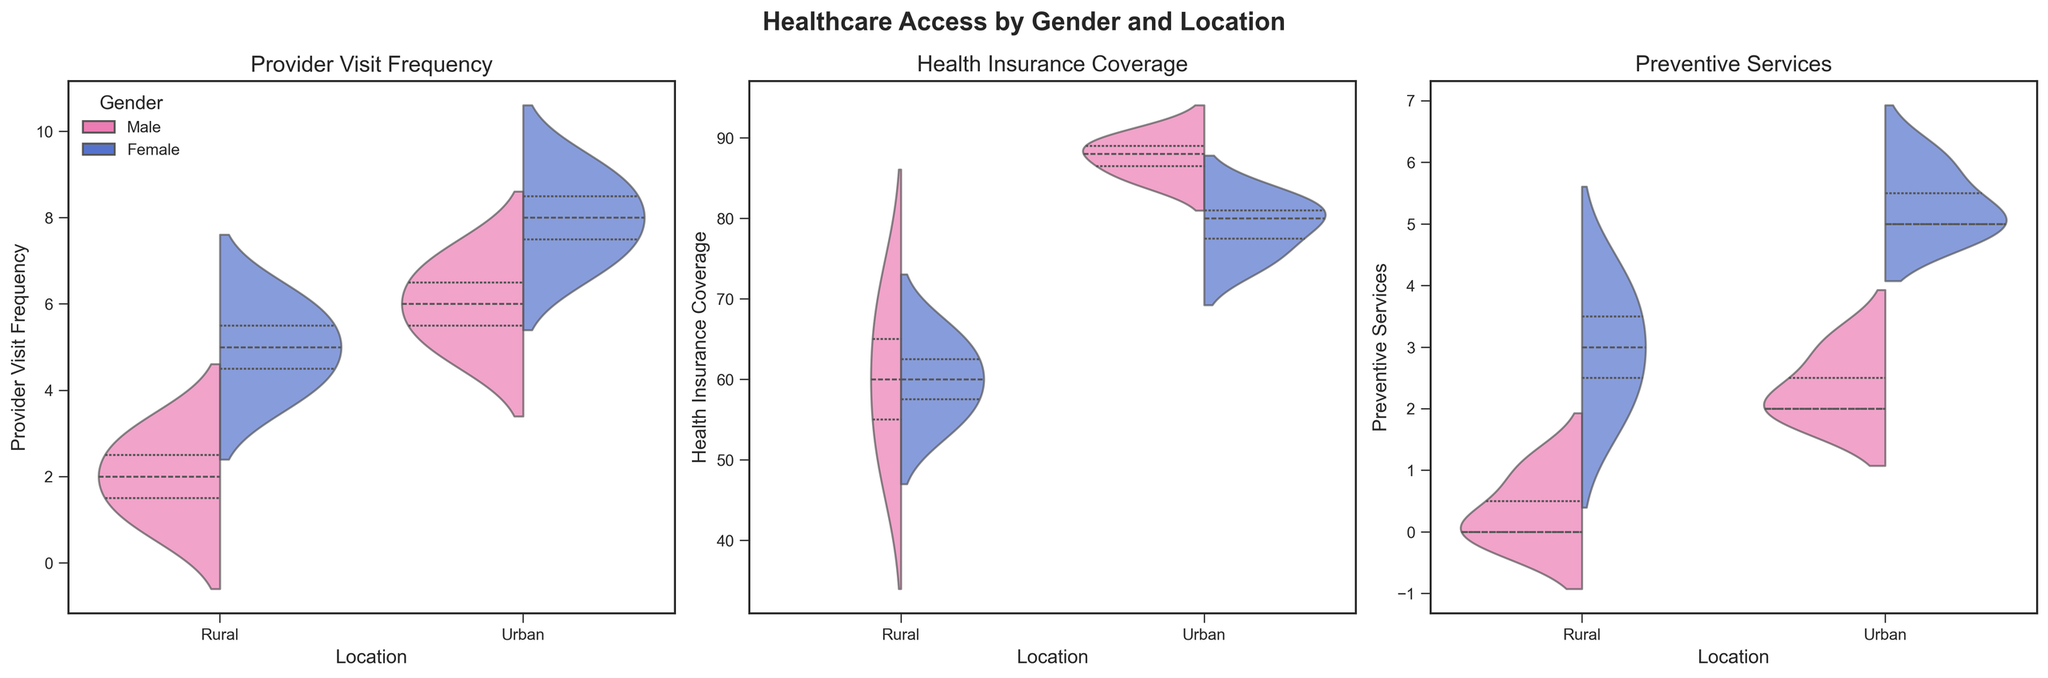What is the title of the first subplot on the left? The title of the first subplot corresponds to the metric being visualized for that subplot. The first subplot on the left visualizes "Provider Visit Frequency".
Answer: Provider Visit Frequency Which group shows the highest median Provider Visit Frequency in urban locations? By looking at the split violin plots for urban locations, the highest median value for Provider Visit Frequency appears in the female group. This is indicated by the thicker part of the violin plot for females in the urban category.
Answer: Urban Females How does the distribution of Health Insurance Coverage compare between rural males and rural females? The violin plot for Health Insurance Coverage shows the distributions. The distribution for rural males is more skewed towards lower values, whereas rural females have a more spread-out distribution, indicating more variability and generally higher coverage.
Answer: Rural females generally have higher coverage What is the difference in the median Preventive Services count between urban males and urban females? For urban males and females, the median can be inferred from the central line in the violin plot. Urban females have a median around 5, while urban males have a median around 2. The difference is 5 - 2.
Answer: 3 Which location and gender group has the widest spread in the Health Insurance Coverage data? The spread of the data in a violin plot is indicated by the width and range of the plot. Rural females have the widest spread in the Health Insurance Coverage dataset, indicated by a very long and spread-out violin plot.
Answer: Rural Females How do the distributions of Preventive Services differ between urban and rural locations for females? The violin plot for females shows that urban locations have a higher count of Preventive Services, with the data skewed towards higher values and a wider spread. In contrast, rural locations show a lower count and a more concentrated distribution.
Answer: Urban females have more Preventive Services Which gender shows a more skewed distribution towards higher values in Health Insurance Coverage in urban locations? By examining the violin plot for urban locations, males show a more skewed distribution towards higher values (mostly between 85 and 90), whereas females have a more uniform distribution.
Answer: Urban Males What can be inferred about Provider Visit Frequency between genders in rural areas based on the plots? The violin plot for rural locations shows that females have a higher Provider Visit Frequency compared to males. The females' median and overall distribution are higher than those of males.
Answer: Females have higher frequencies Which metric shows the most apparent gender disparity in urban locations? By comparing the size and position of the male and female distributions across all figures, Preventive Services in urban locations have the most apparent gender disparity, with females getting significantly more services than males.
Answer: Preventive Services Is there any gender where Preventive Services are notably low across both rural and urban locations? The violin plots for Preventive Services show that males in both rural and urban locations have lower values compared to their female counterparts. The distribution is more concentrated towards lower values.
Answer: Males 